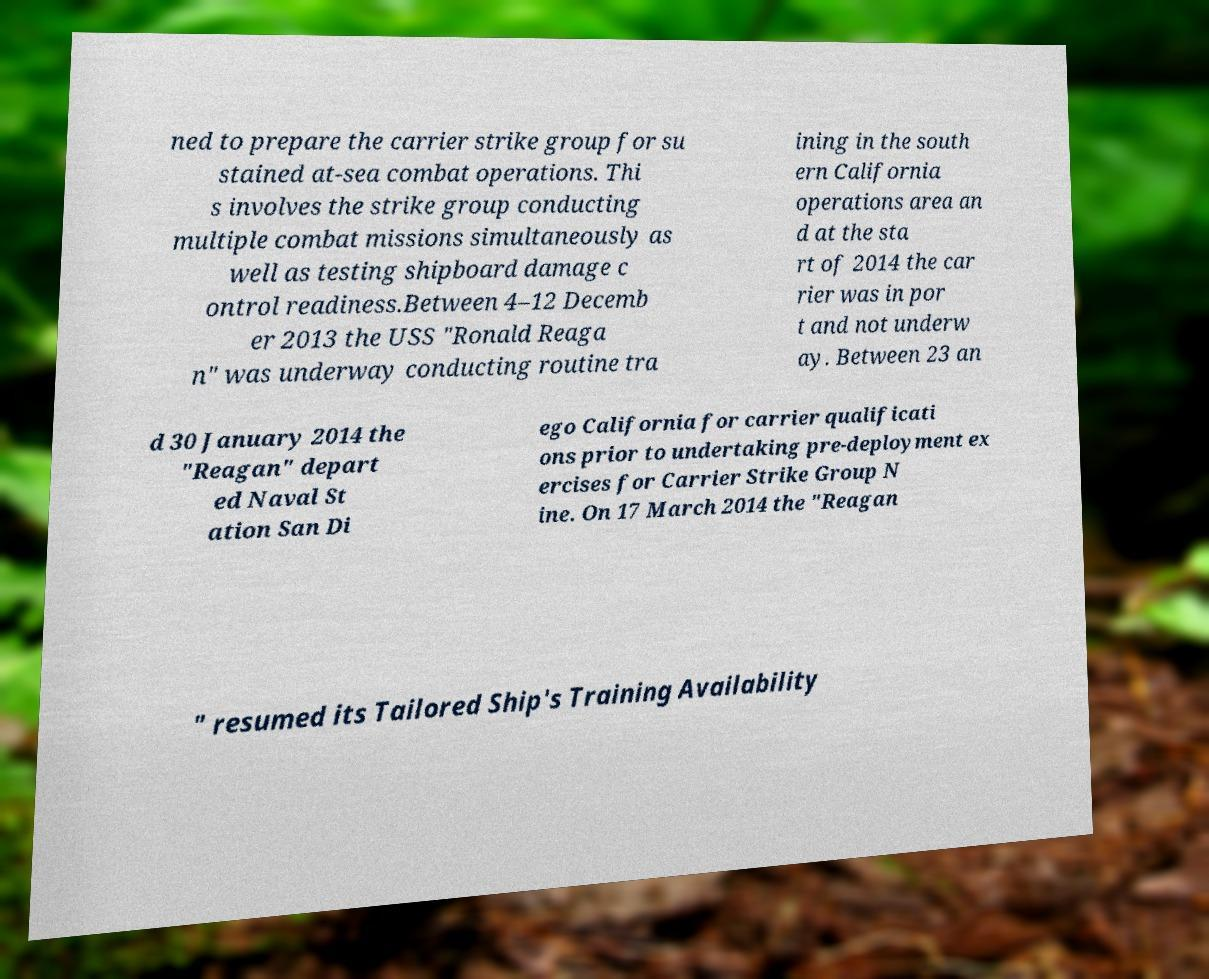Could you extract and type out the text from this image? ned to prepare the carrier strike group for su stained at-sea combat operations. Thi s involves the strike group conducting multiple combat missions simultaneously as well as testing shipboard damage c ontrol readiness.Between 4–12 Decemb er 2013 the USS "Ronald Reaga n" was underway conducting routine tra ining in the south ern California operations area an d at the sta rt of 2014 the car rier was in por t and not underw ay. Between 23 an d 30 January 2014 the "Reagan" depart ed Naval St ation San Di ego California for carrier qualificati ons prior to undertaking pre-deployment ex ercises for Carrier Strike Group N ine. On 17 March 2014 the "Reagan " resumed its Tailored Ship's Training Availability 